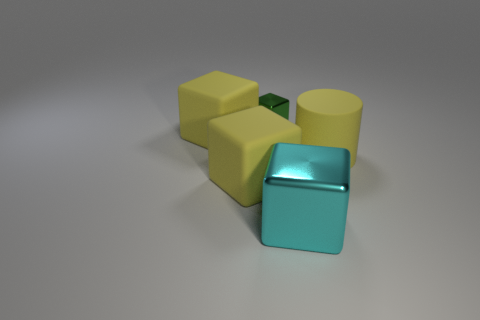How many yellow blocks must be subtracted to get 1 yellow blocks? 1 Add 5 large red blocks. How many objects exist? 10 Subtract all yellow blocks. How many blocks are left? 2 Subtract all tiny metallic cubes. How many cubes are left? 3 Subtract all cubes. How many objects are left? 1 Subtract 1 cylinders. How many cylinders are left? 0 Subtract all green cylinders. Subtract all gray blocks. How many cylinders are left? 1 Subtract all gray blocks. How many purple cylinders are left? 0 Subtract all large cyan metallic cubes. Subtract all large yellow things. How many objects are left? 1 Add 2 tiny cubes. How many tiny cubes are left? 3 